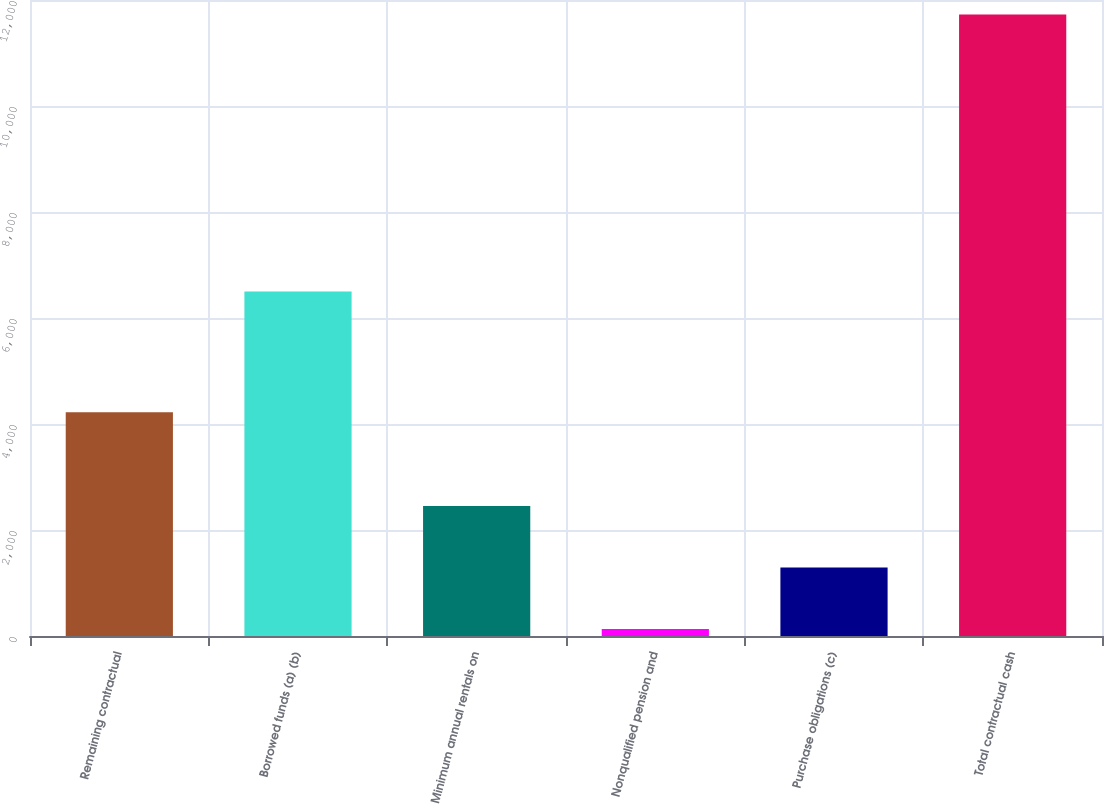Convert chart. <chart><loc_0><loc_0><loc_500><loc_500><bar_chart><fcel>Remaining contractual<fcel>Borrowed funds (a) (b)<fcel>Minimum annual rentals on<fcel>Nonqualified pension and<fcel>Purchase obligations (c)<fcel>Total contractual cash<nl><fcel>4223<fcel>6501<fcel>2451.6<fcel>133<fcel>1292.3<fcel>11726<nl></chart> 